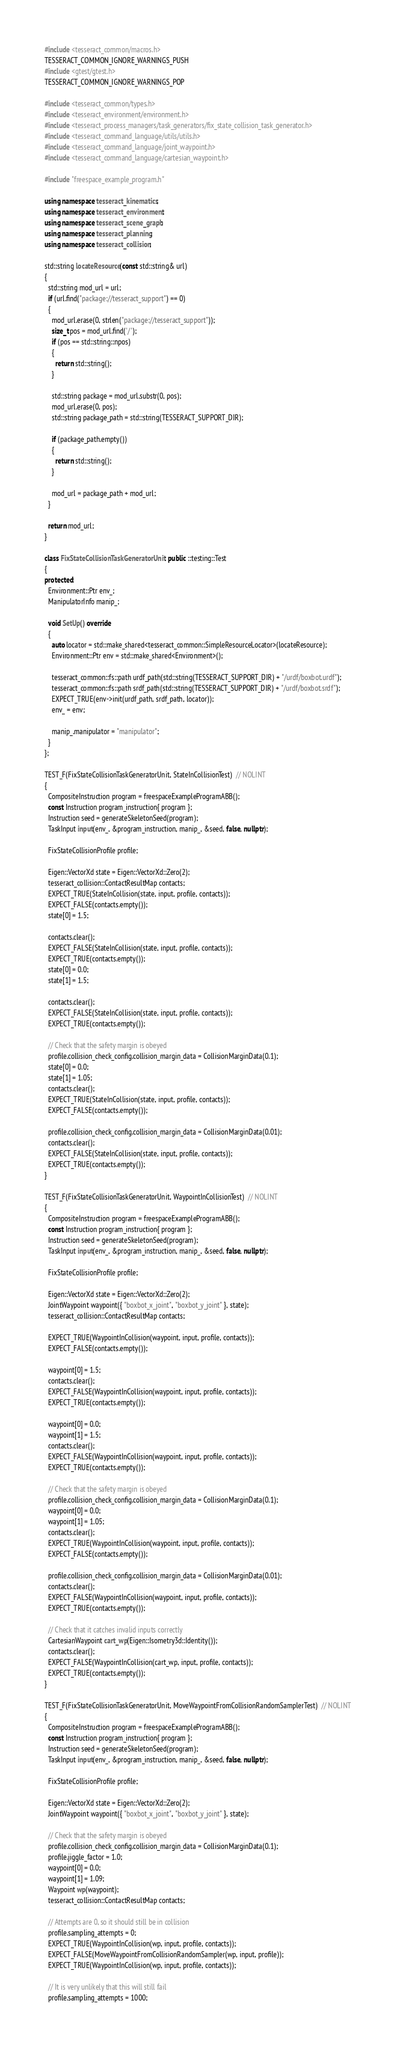Convert code to text. <code><loc_0><loc_0><loc_500><loc_500><_C++_>#include <tesseract_common/macros.h>
TESSERACT_COMMON_IGNORE_WARNINGS_PUSH
#include <gtest/gtest.h>
TESSERACT_COMMON_IGNORE_WARNINGS_POP

#include <tesseract_common/types.h>
#include <tesseract_environment/environment.h>
#include <tesseract_process_managers/task_generators/fix_state_collision_task_generator.h>
#include <tesseract_command_language/utils/utils.h>
#include <tesseract_command_language/joint_waypoint.h>
#include <tesseract_command_language/cartesian_waypoint.h>

#include "freespace_example_program.h"

using namespace tesseract_kinematics;
using namespace tesseract_environment;
using namespace tesseract_scene_graph;
using namespace tesseract_planning;
using namespace tesseract_collision;

std::string locateResource(const std::string& url)
{
  std::string mod_url = url;
  if (url.find("package://tesseract_support") == 0)
  {
    mod_url.erase(0, strlen("package://tesseract_support"));
    size_t pos = mod_url.find('/');
    if (pos == std::string::npos)
    {
      return std::string();
    }

    std::string package = mod_url.substr(0, pos);
    mod_url.erase(0, pos);
    std::string package_path = std::string(TESSERACT_SUPPORT_DIR);

    if (package_path.empty())
    {
      return std::string();
    }

    mod_url = package_path + mod_url;
  }

  return mod_url;
}

class FixStateCollisionTaskGeneratorUnit : public ::testing::Test
{
protected:
  Environment::Ptr env_;
  ManipulatorInfo manip_;

  void SetUp() override
  {
    auto locator = std::make_shared<tesseract_common::SimpleResourceLocator>(locateResource);
    Environment::Ptr env = std::make_shared<Environment>();

    tesseract_common::fs::path urdf_path(std::string(TESSERACT_SUPPORT_DIR) + "/urdf/boxbot.urdf");
    tesseract_common::fs::path srdf_path(std::string(TESSERACT_SUPPORT_DIR) + "/urdf/boxbot.srdf");
    EXPECT_TRUE(env->init(urdf_path, srdf_path, locator));
    env_ = env;

    manip_.manipulator = "manipulator";
  }
};

TEST_F(FixStateCollisionTaskGeneratorUnit, StateInCollisionTest)  // NOLINT
{
  CompositeInstruction program = freespaceExampleProgramABB();
  const Instruction program_instruction{ program };
  Instruction seed = generateSkeletonSeed(program);
  TaskInput input(env_, &program_instruction, manip_, &seed, false, nullptr);

  FixStateCollisionProfile profile;

  Eigen::VectorXd state = Eigen::VectorXd::Zero(2);
  tesseract_collision::ContactResultMap contacts;
  EXPECT_TRUE(StateInCollision(state, input, profile, contacts));
  EXPECT_FALSE(contacts.empty());
  state[0] = 1.5;

  contacts.clear();
  EXPECT_FALSE(StateInCollision(state, input, profile, contacts));
  EXPECT_TRUE(contacts.empty());
  state[0] = 0.0;
  state[1] = 1.5;

  contacts.clear();
  EXPECT_FALSE(StateInCollision(state, input, profile, contacts));
  EXPECT_TRUE(contacts.empty());

  // Check that the safety margin is obeyed
  profile.collision_check_config.collision_margin_data = CollisionMarginData(0.1);
  state[0] = 0.0;
  state[1] = 1.05;
  contacts.clear();
  EXPECT_TRUE(StateInCollision(state, input, profile, contacts));
  EXPECT_FALSE(contacts.empty());

  profile.collision_check_config.collision_margin_data = CollisionMarginData(0.01);
  contacts.clear();
  EXPECT_FALSE(StateInCollision(state, input, profile, contacts));
  EXPECT_TRUE(contacts.empty());
}

TEST_F(FixStateCollisionTaskGeneratorUnit, WaypointInCollisionTest)  // NOLINT
{
  CompositeInstruction program = freespaceExampleProgramABB();
  const Instruction program_instruction{ program };
  Instruction seed = generateSkeletonSeed(program);
  TaskInput input(env_, &program_instruction, manip_, &seed, false, nullptr);

  FixStateCollisionProfile profile;

  Eigen::VectorXd state = Eigen::VectorXd::Zero(2);
  JointWaypoint waypoint({ "boxbot_x_joint", "boxbot_y_joint" }, state);
  tesseract_collision::ContactResultMap contacts;

  EXPECT_TRUE(WaypointInCollision(waypoint, input, profile, contacts));
  EXPECT_FALSE(contacts.empty());

  waypoint[0] = 1.5;
  contacts.clear();
  EXPECT_FALSE(WaypointInCollision(waypoint, input, profile, contacts));
  EXPECT_TRUE(contacts.empty());

  waypoint[0] = 0.0;
  waypoint[1] = 1.5;
  contacts.clear();
  EXPECT_FALSE(WaypointInCollision(waypoint, input, profile, contacts));
  EXPECT_TRUE(contacts.empty());

  // Check that the safety margin is obeyed
  profile.collision_check_config.collision_margin_data = CollisionMarginData(0.1);
  waypoint[0] = 0.0;
  waypoint[1] = 1.05;
  contacts.clear();
  EXPECT_TRUE(WaypointInCollision(waypoint, input, profile, contacts));
  EXPECT_FALSE(contacts.empty());

  profile.collision_check_config.collision_margin_data = CollisionMarginData(0.01);
  contacts.clear();
  EXPECT_FALSE(WaypointInCollision(waypoint, input, profile, contacts));
  EXPECT_TRUE(contacts.empty());

  // Check that it catches invalid inputs correctly
  CartesianWaypoint cart_wp(Eigen::Isometry3d::Identity());
  contacts.clear();
  EXPECT_FALSE(WaypointInCollision(cart_wp, input, profile, contacts));
  EXPECT_TRUE(contacts.empty());
}

TEST_F(FixStateCollisionTaskGeneratorUnit, MoveWaypointFromCollisionRandomSamplerTest)  // NOLINT
{
  CompositeInstruction program = freespaceExampleProgramABB();
  const Instruction program_instruction{ program };
  Instruction seed = generateSkeletonSeed(program);
  TaskInput input(env_, &program_instruction, manip_, &seed, false, nullptr);

  FixStateCollisionProfile profile;

  Eigen::VectorXd state = Eigen::VectorXd::Zero(2);
  JointWaypoint waypoint({ "boxbot_x_joint", "boxbot_y_joint" }, state);

  // Check that the safety margin is obeyed
  profile.collision_check_config.collision_margin_data = CollisionMarginData(0.1);
  profile.jiggle_factor = 1.0;
  waypoint[0] = 0.0;
  waypoint[1] = 1.09;
  Waypoint wp(waypoint);
  tesseract_collision::ContactResultMap contacts;

  // Attempts are 0, so it should still be in collision
  profile.sampling_attempts = 0;
  EXPECT_TRUE(WaypointInCollision(wp, input, profile, contacts));
  EXPECT_FALSE(MoveWaypointFromCollisionRandomSampler(wp, input, profile));
  EXPECT_TRUE(WaypointInCollision(wp, input, profile, contacts));

  // It is very unlikely that this will still fail
  profile.sampling_attempts = 1000;</code> 